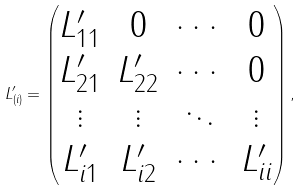<formula> <loc_0><loc_0><loc_500><loc_500>L _ { ( i ) } ^ { \prime } = \begin{pmatrix} L _ { 1 1 } ^ { \prime } & 0 & \cdots & 0 \\ L _ { 2 1 } ^ { \prime } & L _ { 2 2 } ^ { \prime } & \cdots & 0 \\ \vdots & \vdots & \ddots & \vdots \\ L _ { i 1 } ^ { \prime } & L _ { i 2 } ^ { \prime } & \cdots & L _ { i i } ^ { \prime } \end{pmatrix} ,</formula> 